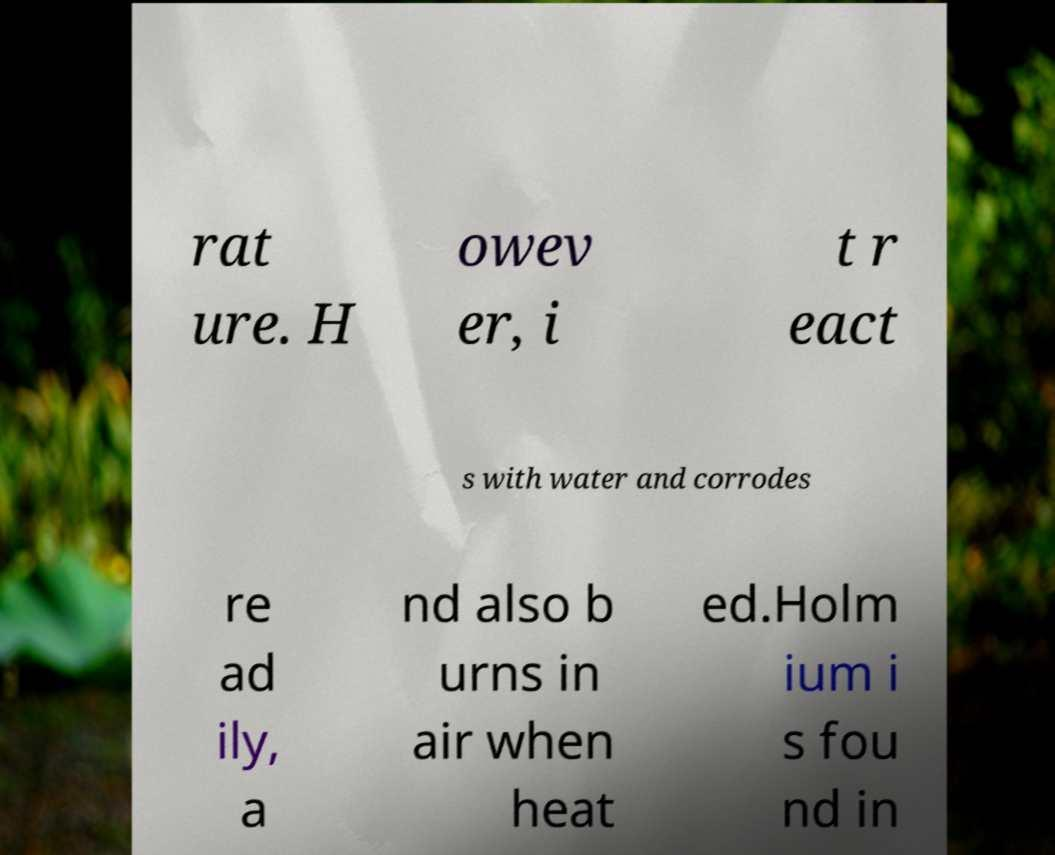What messages or text are displayed in this image? I need them in a readable, typed format. rat ure. H owev er, i t r eact s with water and corrodes re ad ily, a nd also b urns in air when heat ed.Holm ium i s fou nd in 